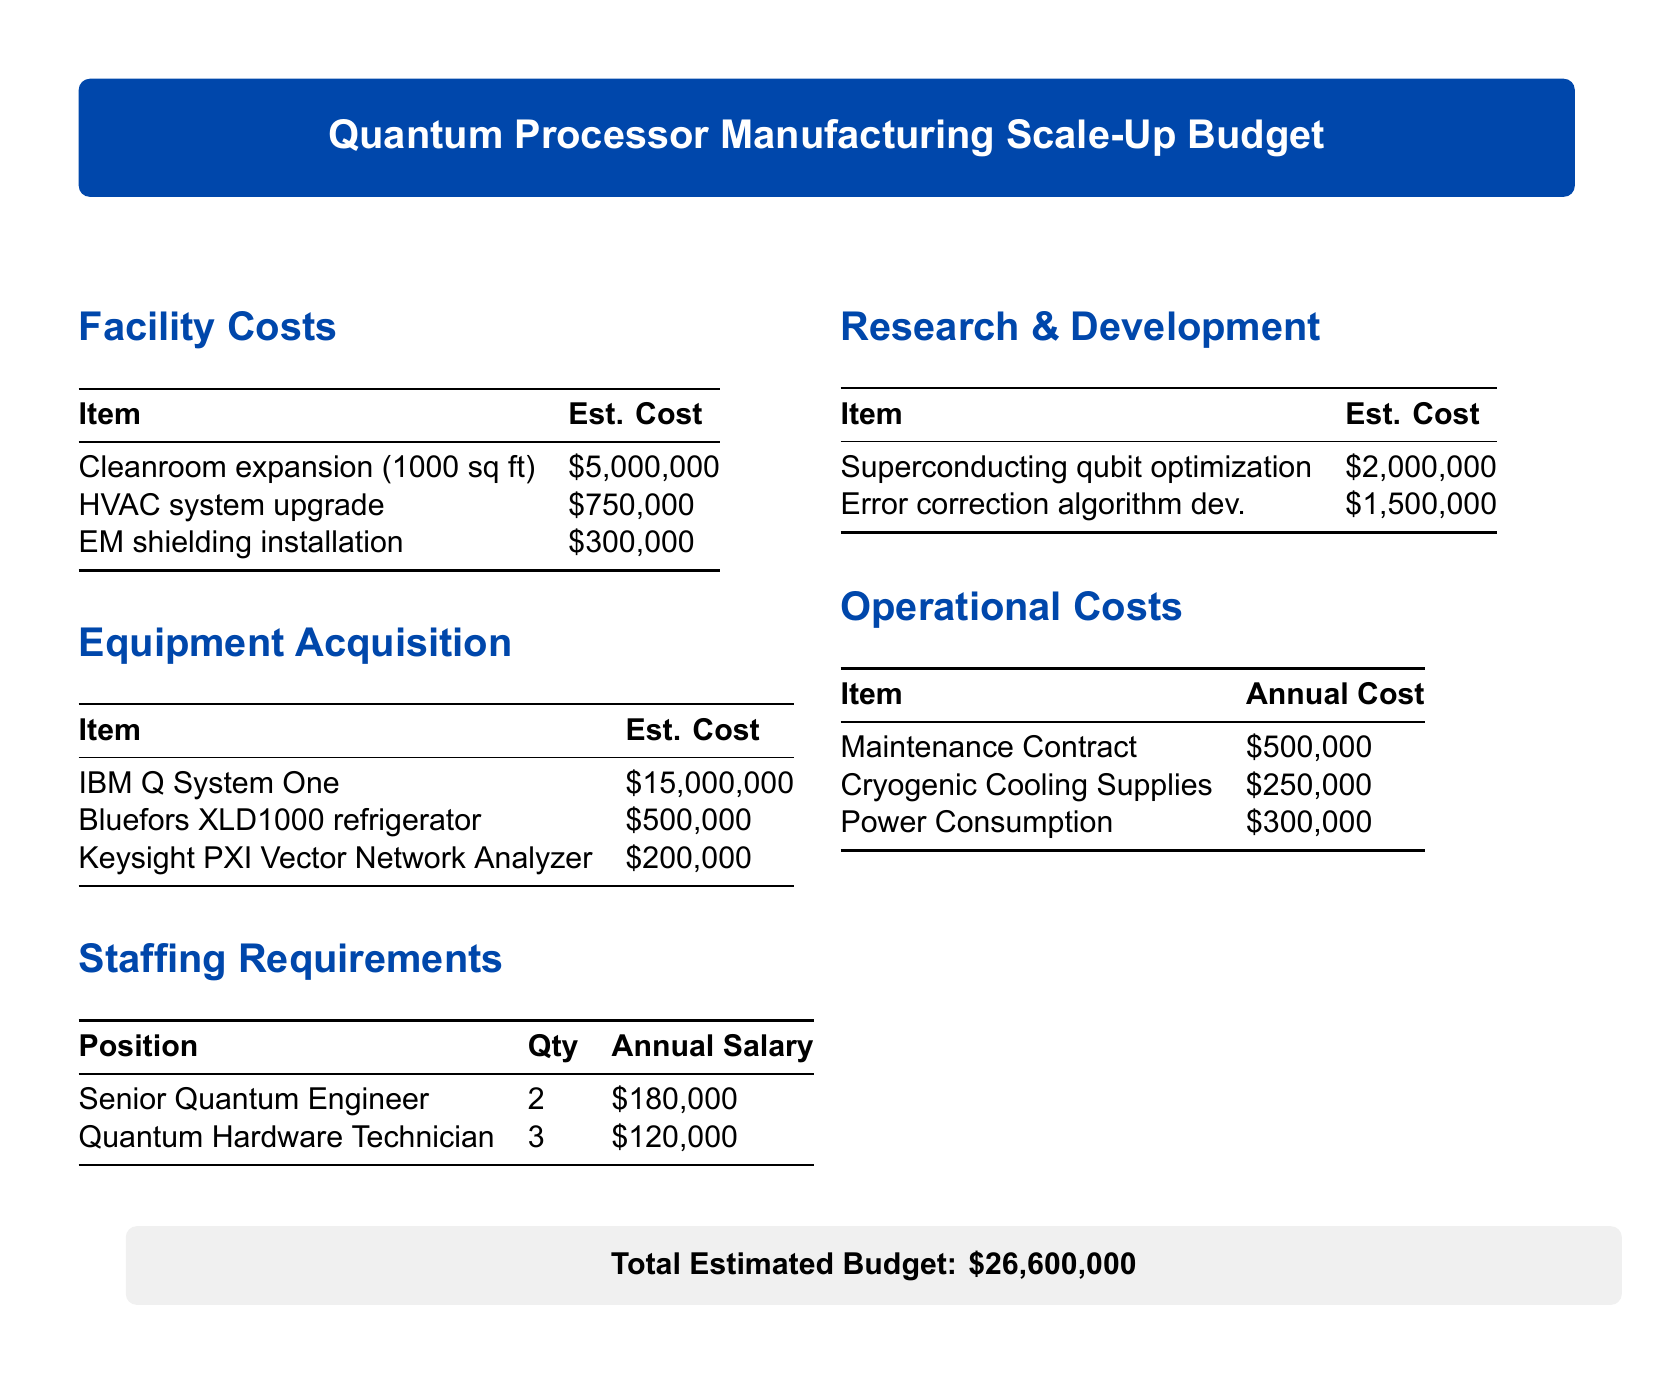What is the estimated cost of cleanroom expansion? The estimated cost for cleanroom expansion is listed in the facility costs section of the document as $5,000,000.
Answer: $5,000,000 How many Senior Quantum Engineers are required? The staffing requirements section states that 2 Senior Quantum Engineers are needed for the project.
Answer: 2 What is the total estimated budget? The total estimated budget is provided at the end of the document as the cumulative cost of all listed items, which is $26,600,000.
Answer: $26,600,000 What is the annual cost for cryogenic cooling supplies? The operational costs section specifies that the annual cost for cryogenic cooling supplies is $250,000.
Answer: $250,000 How much does the IBM Q System One cost? The equipment acquisition section cites the cost of the IBM Q System One as $15,000,000.
Answer: $15,000,000 What is the estimated cost for error correction algorithm development? The research and development section mentions the estimated cost for error correction algorithm development as $1,500,000.
Answer: $1,500,000 How many Quantum Hardware Technicians will be hired? The staffing requirements section indicates that 3 Quantum Hardware Technicians will be hired.
Answer: 3 What is the estimated cost for the HVAC system upgrade? The facility costs section lists the estimated cost for the HVAC system upgrade as $750,000.
Answer: $750,000 Which item has the highest estimated cost in equipment acquisition? The IBM Q System One has the highest estimated cost in the equipment acquisition section, which is $15,000,000.
Answer: IBM Q System One 